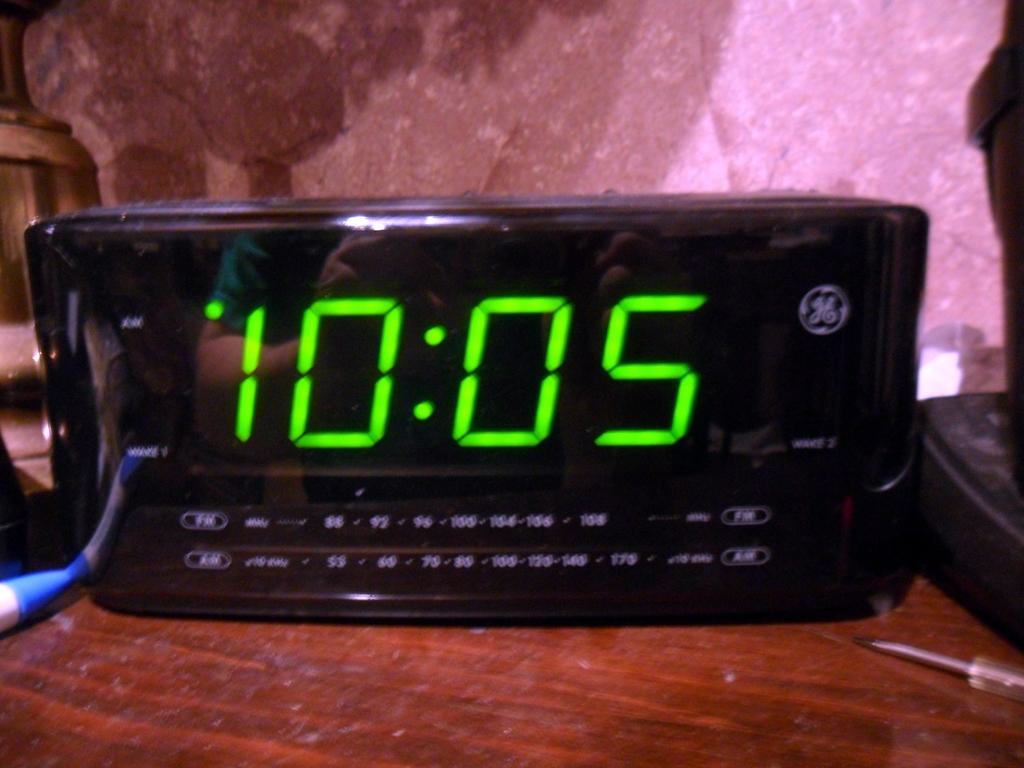What number is underneath the painting?
Give a very brief answer. Unanswerable. Is this clock a ge?
Provide a short and direct response. Yes. 